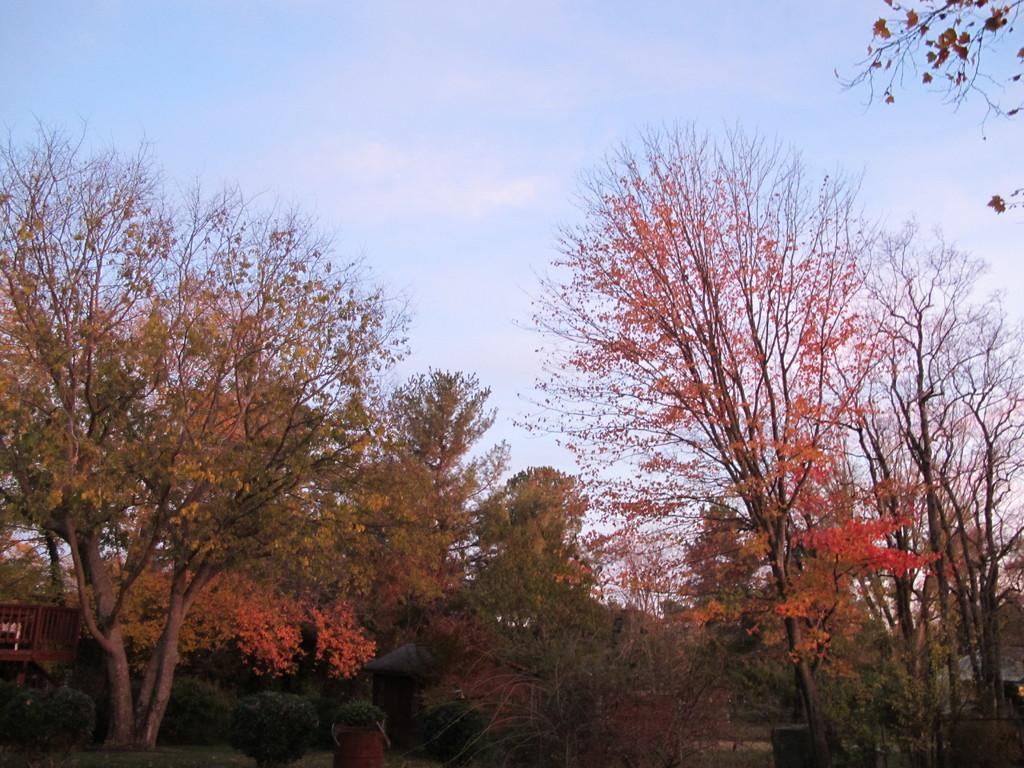What type of vegetation can be seen in the image? There are trees in the image. What part of the natural environment is visible in the image? The sky is visible in the background of the image. Can you describe any other objects in the image besides the trees and sky? Unfortunately, the provided facts do not specify any other objects in the image. What type of potato is being held by the dad in the image? There is no dad or potato present in the image. Can you describe the monkey's interaction with the trees in the image? There is no monkey present in the image. 